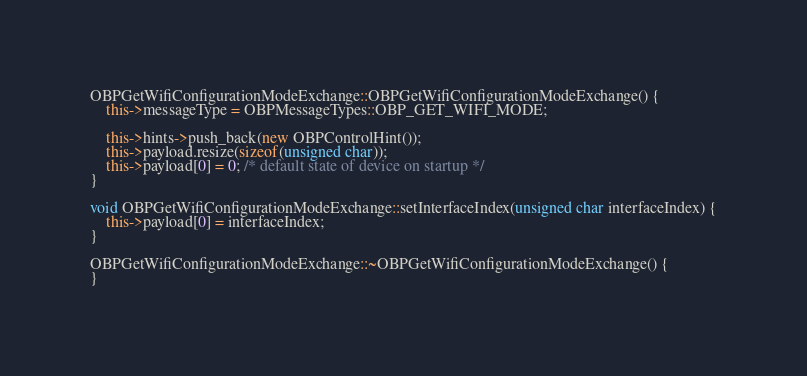<code> <loc_0><loc_0><loc_500><loc_500><_C++_>OBPGetWifiConfigurationModeExchange::OBPGetWifiConfigurationModeExchange() {
	this->messageType = OBPMessageTypes::OBP_GET_WIFI_MODE;

	this->hints->push_back(new OBPControlHint());
	this->payload.resize(sizeof(unsigned char));
	this->payload[0] = 0; /* default state of device on startup */
}

void OBPGetWifiConfigurationModeExchange::setInterfaceIndex(unsigned char interfaceIndex) {
	this->payload[0] = interfaceIndex;
}

OBPGetWifiConfigurationModeExchange::~OBPGetWifiConfigurationModeExchange() {
}
</code> 